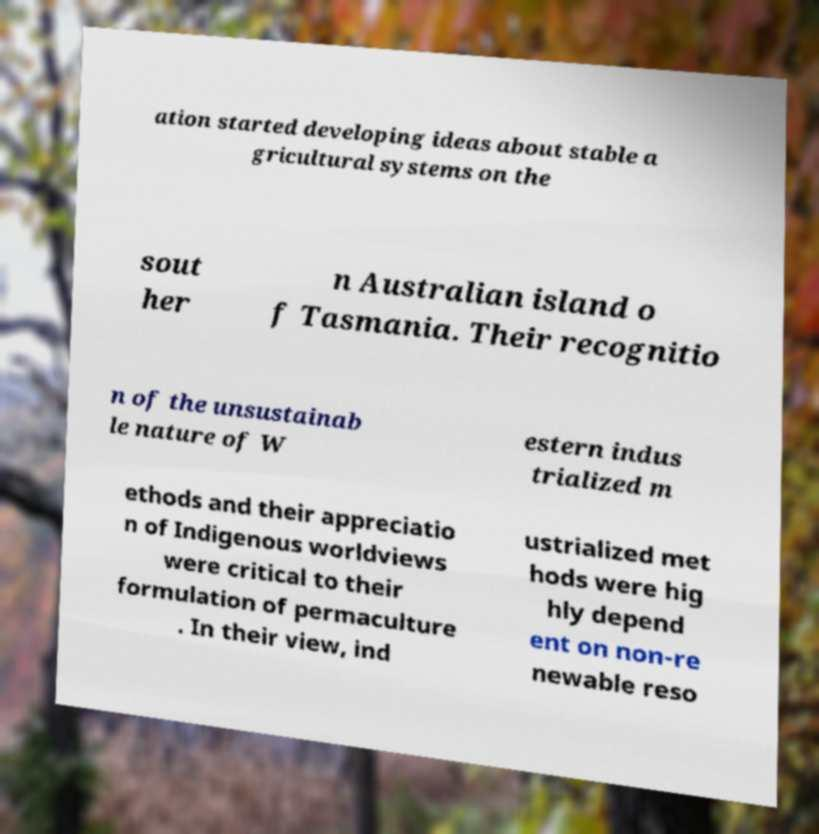There's text embedded in this image that I need extracted. Can you transcribe it verbatim? ation started developing ideas about stable a gricultural systems on the sout her n Australian island o f Tasmania. Their recognitio n of the unsustainab le nature of W estern indus trialized m ethods and their appreciatio n of Indigenous worldviews were critical to their formulation of permaculture . In their view, ind ustrialized met hods were hig hly depend ent on non-re newable reso 